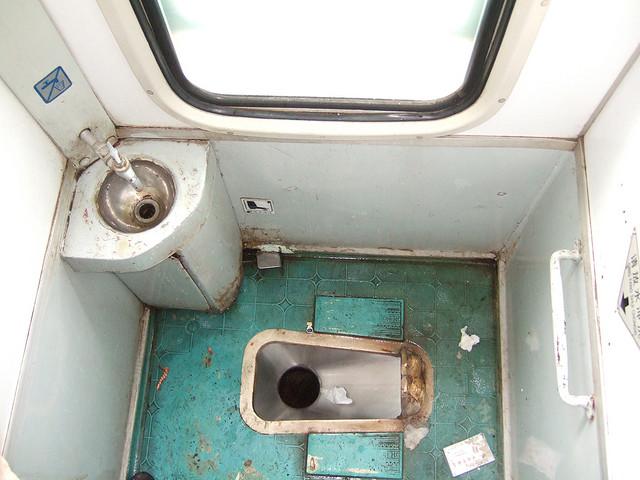Is this a good place to prepare food?
Be succinct. No. Does this area look clean?
Give a very brief answer. No. Is there a toilet in the image?
Write a very short answer. Yes. 